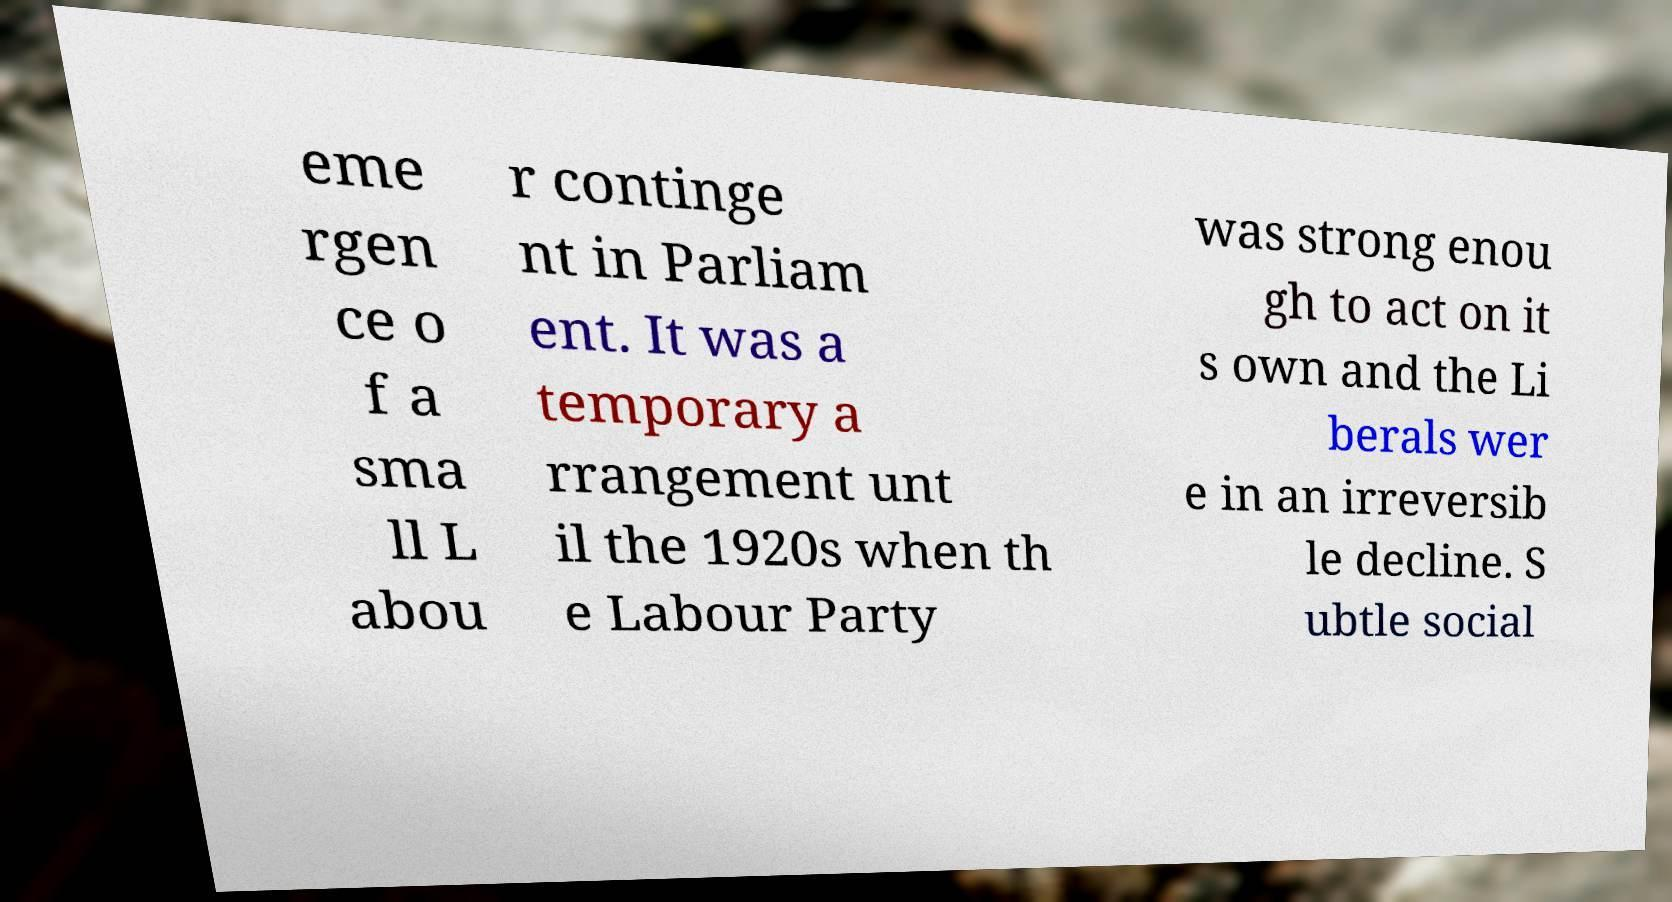There's text embedded in this image that I need extracted. Can you transcribe it verbatim? eme rgen ce o f a sma ll L abou r continge nt in Parliam ent. It was a temporary a rrangement unt il the 1920s when th e Labour Party was strong enou gh to act on it s own and the Li berals wer e in an irreversib le decline. S ubtle social 